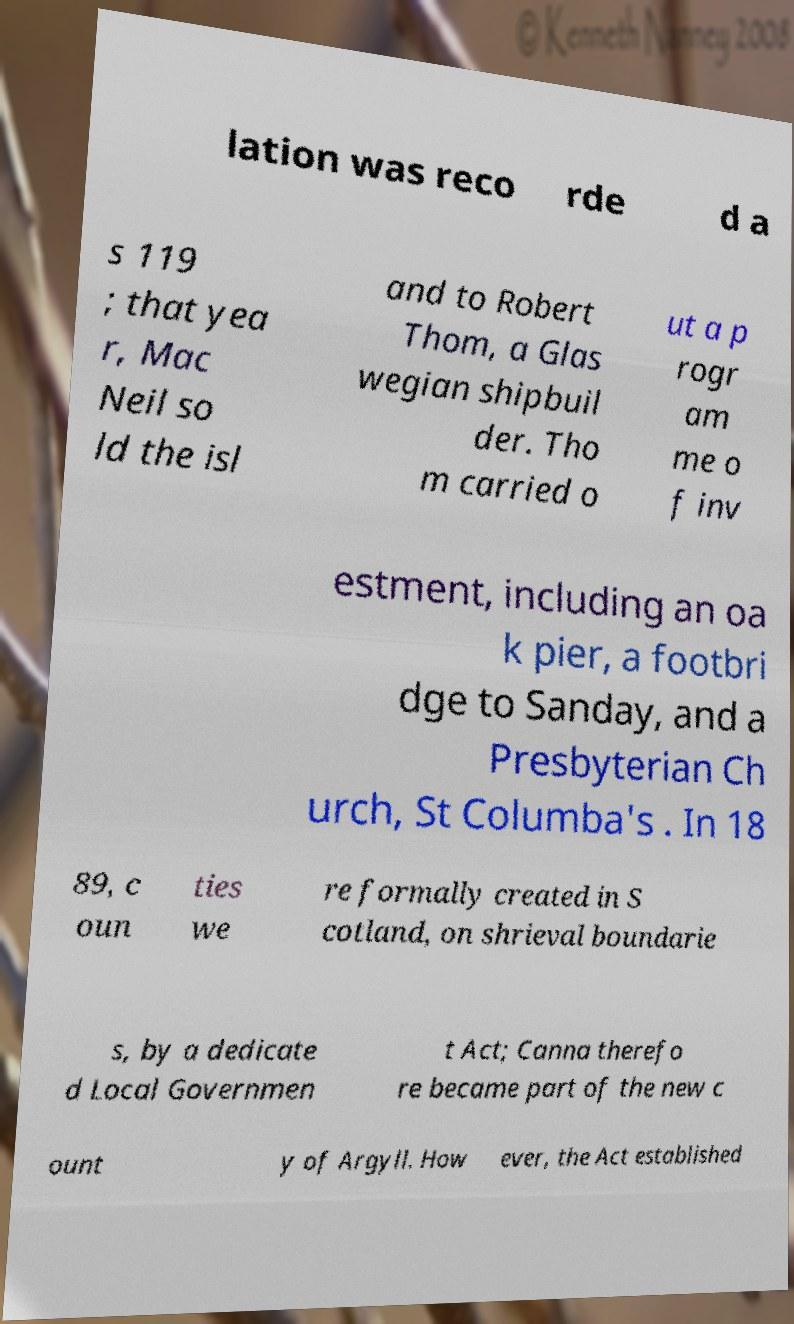There's text embedded in this image that I need extracted. Can you transcribe it verbatim? lation was reco rde d a s 119 ; that yea r, Mac Neil so ld the isl and to Robert Thom, a Glas wegian shipbuil der. Tho m carried o ut a p rogr am me o f inv estment, including an oa k pier, a footbri dge to Sanday, and a Presbyterian Ch urch, St Columba's . In 18 89, c oun ties we re formally created in S cotland, on shrieval boundarie s, by a dedicate d Local Governmen t Act; Canna therefo re became part of the new c ount y of Argyll. How ever, the Act established 